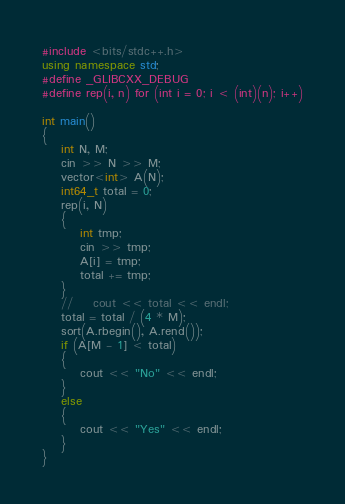<code> <loc_0><loc_0><loc_500><loc_500><_C++_>#include <bits/stdc++.h>
using namespace std;
#define _GLIBCXX_DEBUG
#define rep(i, n) for (int i = 0; i < (int)(n); i++)

int main()
{
    int N, M;
    cin >> N >> M;
    vector<int> A(N);
    int64_t total = 0;
    rep(i, N)
    {
        int tmp;
        cin >> tmp;
        A[i] = tmp;
        total += tmp;
    }
    //    cout << total << endl;
    total = total / (4 * M);
    sort(A.rbegin(), A.rend());
    if (A[M - 1] < total)
    {
        cout << "No" << endl;
    }
    else
    {
        cout << "Yes" << endl;
    }
}</code> 